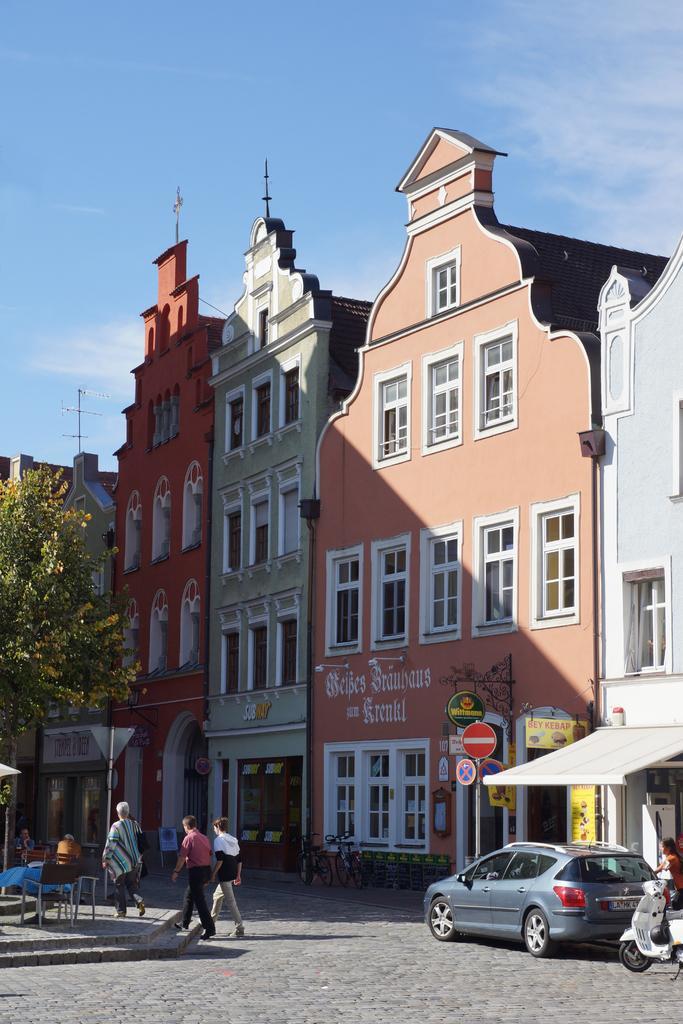Can you describe this image briefly? There are people walking and we can see vehicles on the road, chairs and table. We can see buildings, boards on poles, lights and tree. In the background we can see sky. 